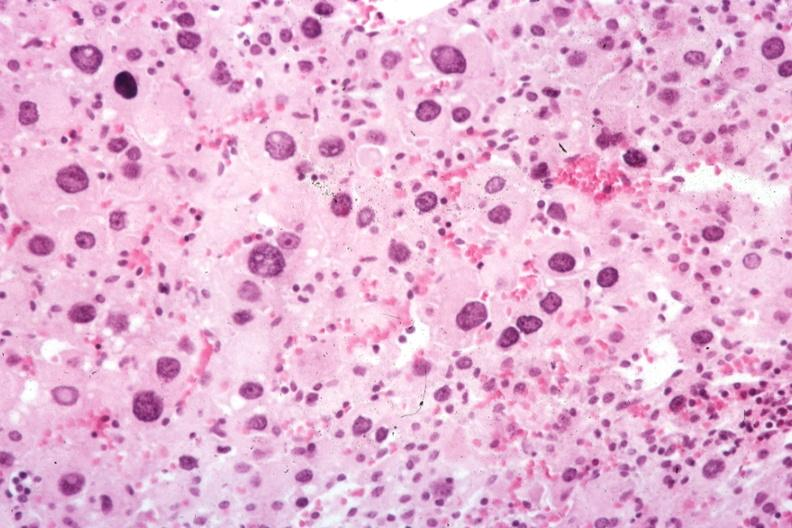s outside adrenal capsule section present?
Answer the question using a single word or phrase. No 